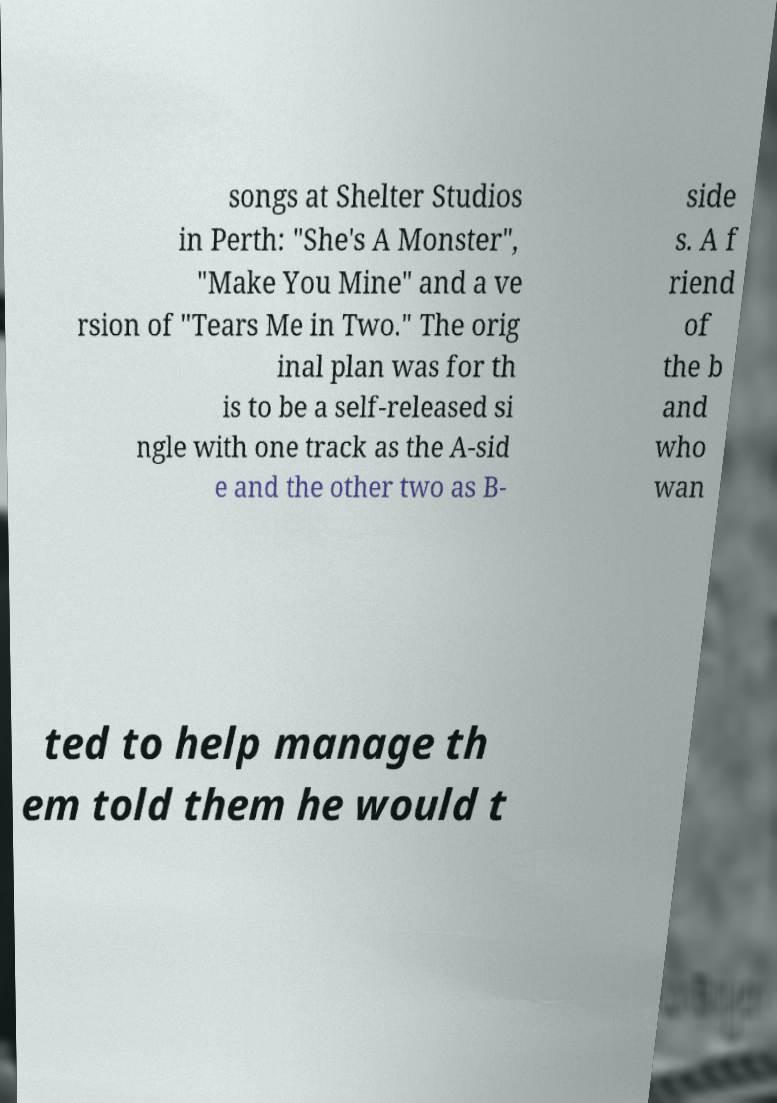Could you extract and type out the text from this image? songs at Shelter Studios in Perth: "She's A Monster", "Make You Mine" and a ve rsion of "Tears Me in Two." The orig inal plan was for th is to be a self-released si ngle with one track as the A-sid e and the other two as B- side s. A f riend of the b and who wan ted to help manage th em told them he would t 